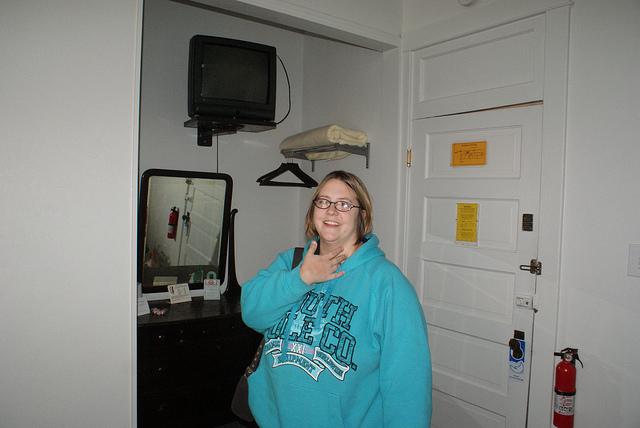Is she wearing a summer dress?
Concise answer only. No. What is the color of the door?
Keep it brief. White. Is TV onIs TV on or off?
Concise answer only. Off. What is the picture on the person's shirt?
Give a very brief answer. Letters. Where was this photo taken?
Write a very short answer. Bedroom. How many stripes are visible?
Keep it brief. 0. Where is the TV at in the room?
Short answer required. Yes. What item of clothing is the woman wearing?
Keep it brief. Sweatshirt. Is the woman playing a game?
Write a very short answer. No. What this people are trying to do?
Short answer required. Smile. Is the woman alighting?
Be succinct. No. Are they playing a group game?
Short answer required. No. What piece of safety equipment is in this room?
Give a very brief answer. Fire extinguisher. How many of the people in this photo are carrying a surfboard?
Quick response, please. 0. What color is the woman's shirt?
Be succinct. Blue. Was this taken during a holiday celebration?
Short answer required. No. What word is in the center of the paper taped to the wall?
Concise answer only. Can't see. Are the doors opened or closed?
Short answer required. Closed. How warm is it?
Answer briefly. Lukewarm. Is that a man?
Answer briefly. No. 